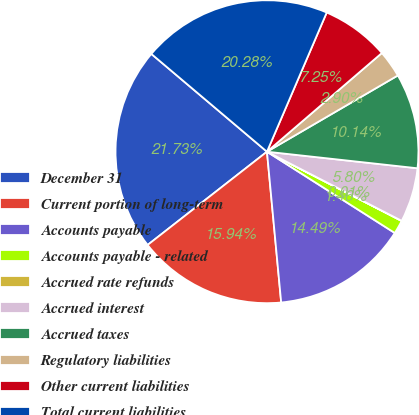<chart> <loc_0><loc_0><loc_500><loc_500><pie_chart><fcel>December 31<fcel>Current portion of long-term<fcel>Accounts payable<fcel>Accounts payable - related<fcel>Accrued rate refunds<fcel>Accrued interest<fcel>Accrued taxes<fcel>Regulatory liabilities<fcel>Other current liabilities<fcel>Total current liabilities<nl><fcel>21.73%<fcel>15.94%<fcel>14.49%<fcel>1.46%<fcel>0.01%<fcel>5.8%<fcel>10.14%<fcel>2.9%<fcel>7.25%<fcel>20.28%<nl></chart> 